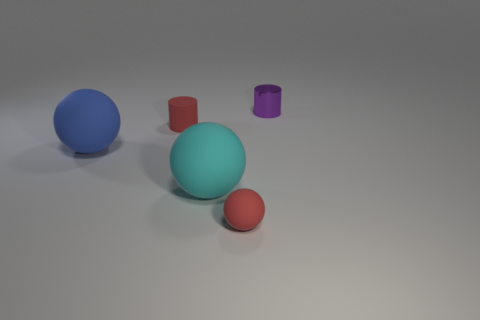The red matte object behind the large ball on the left side of the matte thing that is behind the blue ball is what shape?
Offer a terse response. Cylinder. There is a cylinder that is on the left side of the purple metallic thing; is it the same color as the large matte ball in front of the blue ball?
Ensure brevity in your answer.  No. How many cyan objects are there?
Give a very brief answer. 1. Are there any red balls right of the cyan sphere?
Offer a very short reply. Yes. Is the material of the tiny cylinder that is left of the red matte ball the same as the big thing that is right of the tiny matte cylinder?
Keep it short and to the point. Yes. Is the number of small metallic cylinders that are on the right side of the small purple metallic thing less than the number of small purple things?
Give a very brief answer. Yes. There is a tiny rubber object on the left side of the small ball; what color is it?
Give a very brief answer. Red. What material is the cylinder that is on the left side of the purple shiny thing to the right of the matte cylinder made of?
Make the answer very short. Rubber. Are there any red rubber spheres of the same size as the purple shiny thing?
Ensure brevity in your answer.  Yes. How many objects are either tiny cylinders to the left of the tiny purple object or big spheres to the right of the big blue rubber object?
Give a very brief answer. 2. 